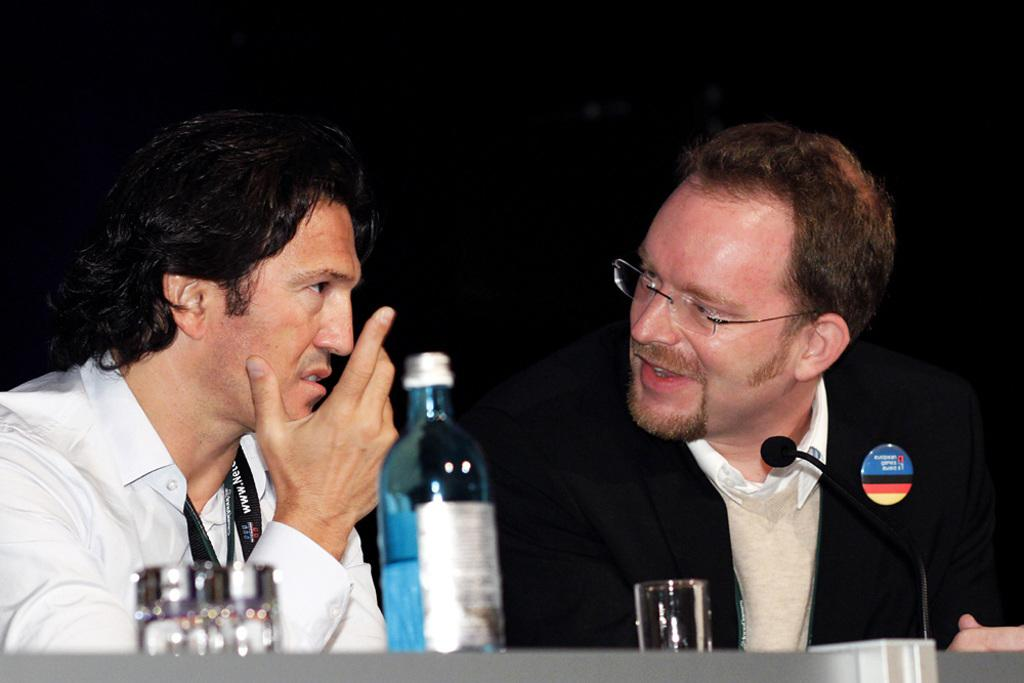How many people are in the image? There are two men in the image. What are the men doing in the image? The men are sitting in front of a table. What objects can be seen on the table? There is a bottle and two glasses on the table. What can be inferred about the lighting in the image? The background of the image is dark. What type of knife is being used to cut the comfort in the image? There is no knife or comfort present in the image. Is there a party happening in the image? The image does not show any indication of a party taking place. 